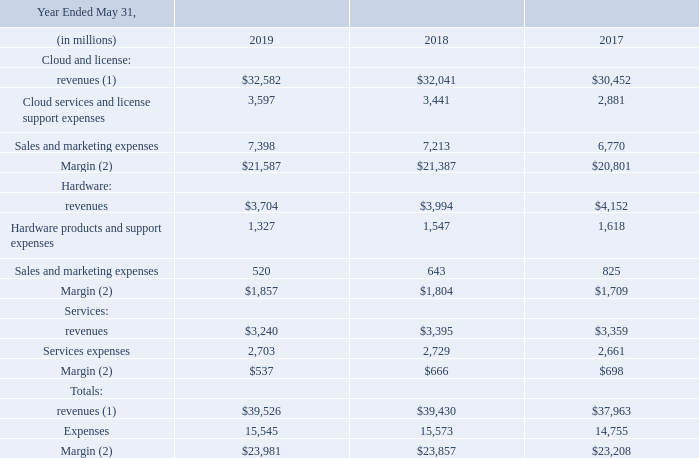The following table presents summary results for each of our three businesses for each of fiscal 2019 , 2018 and 2017 :
(1) Cloud and license revenues presented for management reporting included revenues related to cloud and license obligations that would have otherwise been recorded by the acquired businesses as independent entities but were not recognized in our consolidated statements of operations for the periods presented due to business combination accounting requirements. See Note 9 for an explanation of these adjustments and the table below for a reconciliation of our total operating segment revenues to our total consolidated revenues as reported in our consolidated statements of operations
(2) The margins reported reflect only the direct controllable costs of each line of business and do not include allocations of product development, general and administrative and certain other allocable expenses, net. Additionally, the margins reported above do not reflect amortization of intangible assets, acquisition related and other expenses, restructuring expenses, stock-based compensation, interest expense or non-operating income, net. refer to the table below for a reconciliation of our total margin for operating segments to our income before provision for income taxes as reported per our consolidated statements of operations.
What was the percentage change in hardware revenues from 2017 to 2018?
Answer scale should be: percent. (3,994-4,152)/4,152 
Answer: -3.81. How much was the total revenue for cloud and license business and services business in 2019?
Answer scale should be: million. 3,240+32,582 
Answer: 35822. What was the difference in total expenses in 2019 and 2017?
Answer scale should be: million. 15,545 - 14,755 
Answer: 790. Do the margins reported reflect amortization of intangible assets? Additionally, the margins reported above do not reflect amortization of intangible assets. Why were revenues related to cloud and license obligations not recognized in the consolidated statements of operations for the periods presented? Cloud and license revenues presented for management reporting included revenues related to cloud and license obligations that would have otherwise been recorded by the acquired businesses as independent entities but were not recognized in our consolidated statements of operations for the periods presented due to business combination accounting requirements. Which note can one refer to for an explanation of adjustments made? See note 9 for an explanation of these adjustments and the table below for a reconciliation of our total operating segment revenues to our total consolidated revenues as reported in our consolidated statements of operations. 